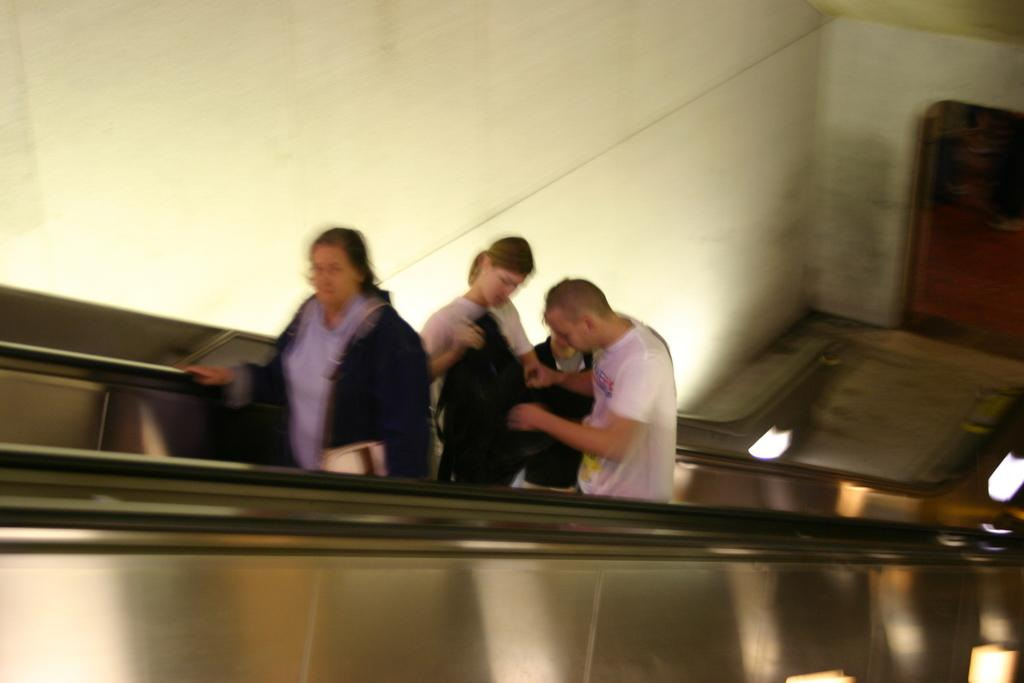How many people are standing on the staircase in the foreground? There are four persons standing on the staircase in the foreground. What can be seen in the background of the image? There is a wall and a door in the background. Where was the image taken? The image was taken inside a building. What color is the error message displayed on the wall in the background? There is no error message displayed on the wall in the background; it is just a wall. How many parents are visible in the image? There is no mention of parents in the image; it features four persons standing on the staircase. 